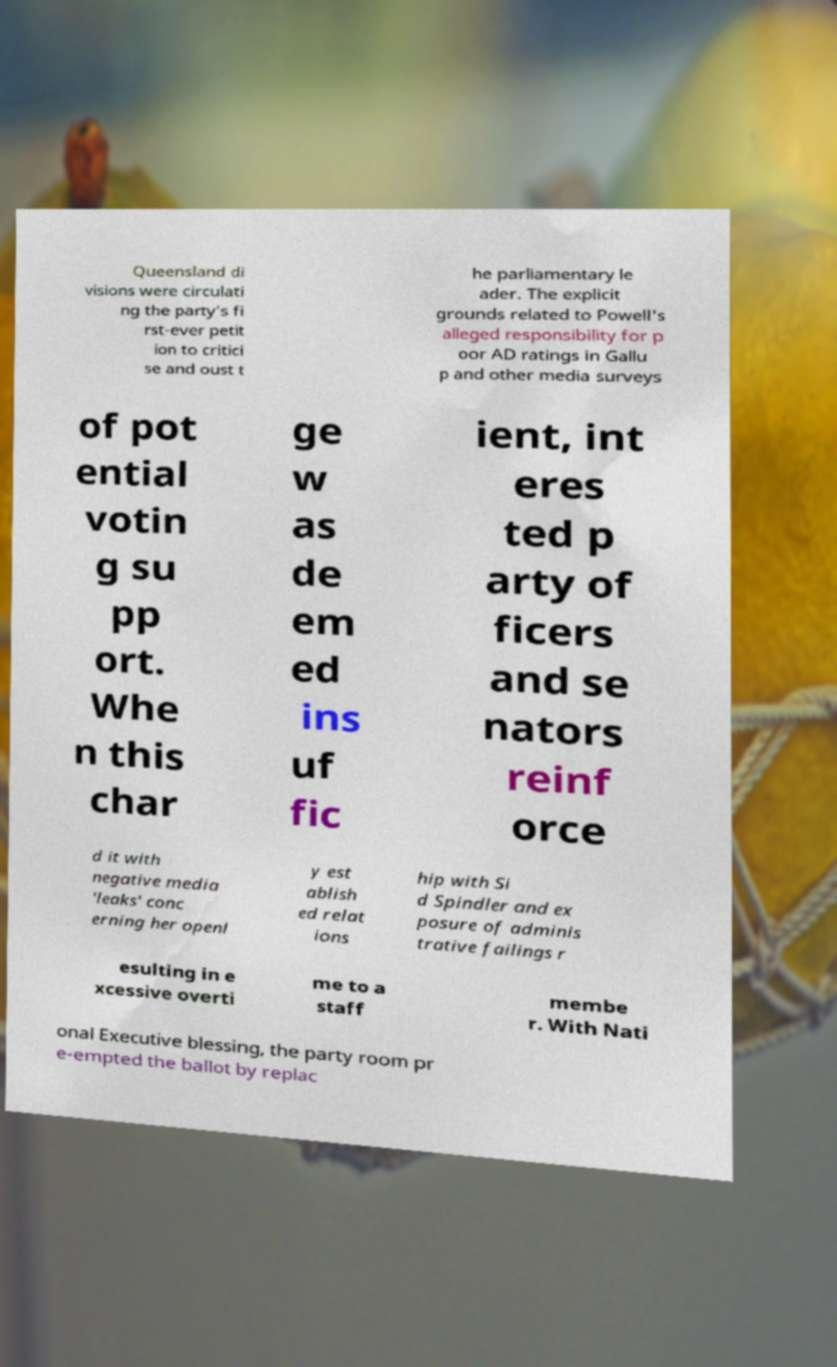Can you read and provide the text displayed in the image?This photo seems to have some interesting text. Can you extract and type it out for me? Queensland di visions were circulati ng the party's fi rst-ever petit ion to critici se and oust t he parliamentary le ader. The explicit grounds related to Powell's alleged responsibility for p oor AD ratings in Gallu p and other media surveys of pot ential votin g su pp ort. Whe n this char ge w as de em ed ins uf fic ient, int eres ted p arty of ficers and se nators reinf orce d it with negative media 'leaks' conc erning her openl y est ablish ed relat ions hip with Si d Spindler and ex posure of adminis trative failings r esulting in e xcessive overti me to a staff membe r. With Nati onal Executive blessing, the party room pr e-empted the ballot by replac 